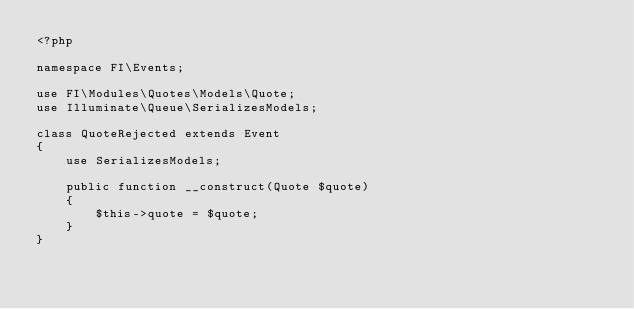Convert code to text. <code><loc_0><loc_0><loc_500><loc_500><_PHP_><?php

namespace FI\Events;

use FI\Modules\Quotes\Models\Quote;
use Illuminate\Queue\SerializesModels;

class QuoteRejected extends Event
{
    use SerializesModels;

    public function __construct(Quote $quote)
    {
        $this->quote = $quote;
    }
}</code> 